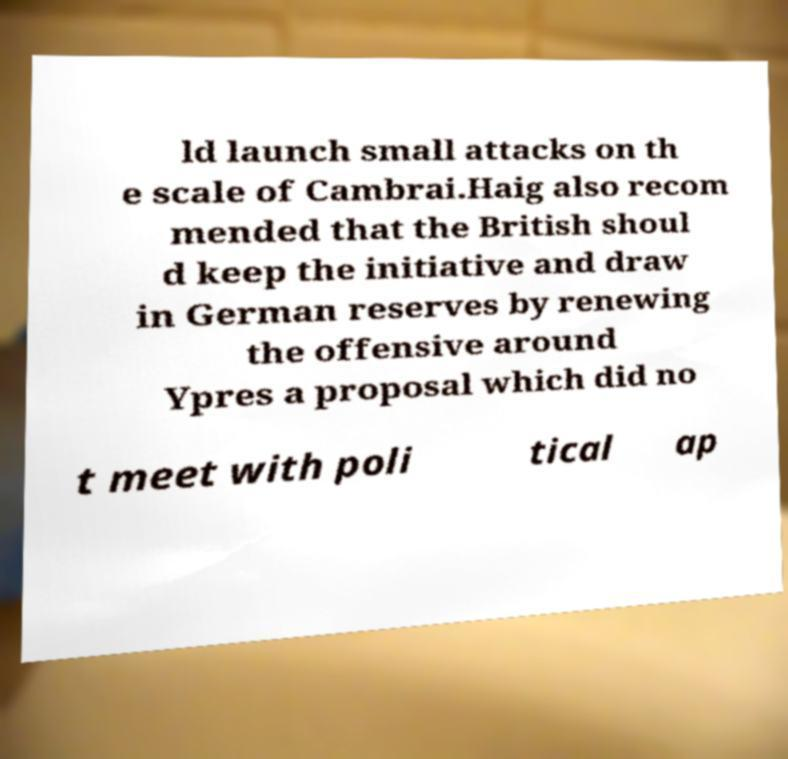For documentation purposes, I need the text within this image transcribed. Could you provide that? ld launch small attacks on th e scale of Cambrai.Haig also recom mended that the British shoul d keep the initiative and draw in German reserves by renewing the offensive around Ypres a proposal which did no t meet with poli tical ap 